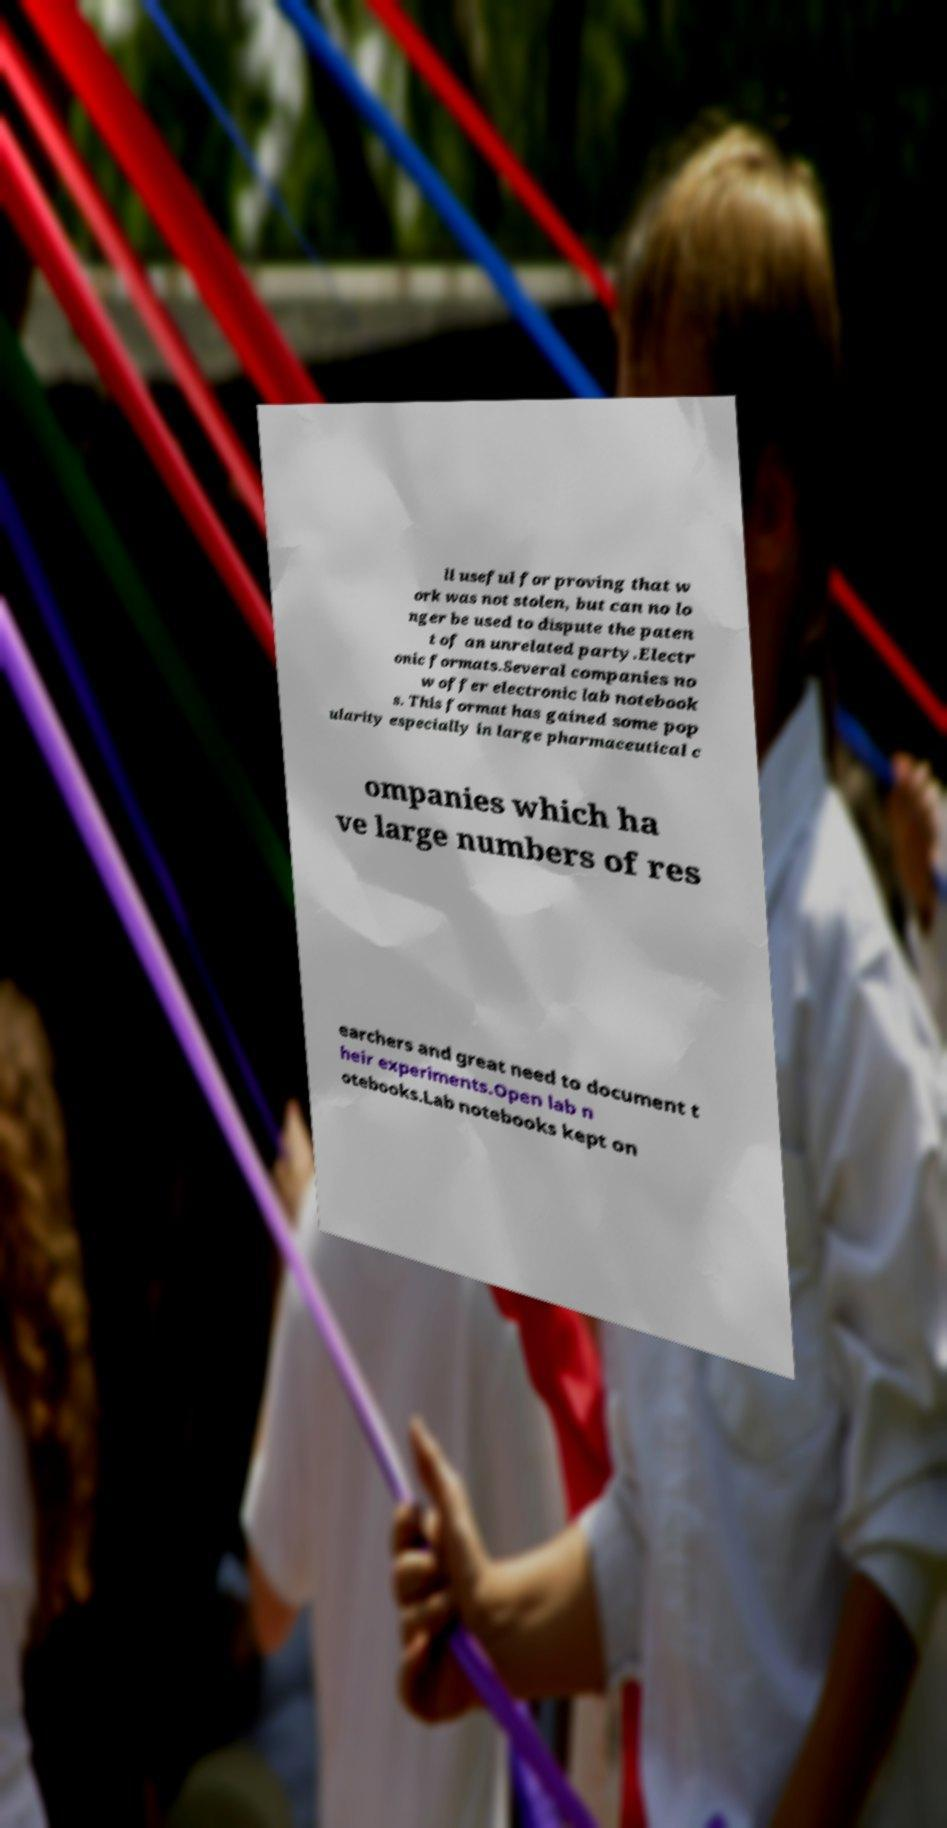For documentation purposes, I need the text within this image transcribed. Could you provide that? ll useful for proving that w ork was not stolen, but can no lo nger be used to dispute the paten t of an unrelated party.Electr onic formats.Several companies no w offer electronic lab notebook s. This format has gained some pop ularity especially in large pharmaceutical c ompanies which ha ve large numbers of res earchers and great need to document t heir experiments.Open lab n otebooks.Lab notebooks kept on 